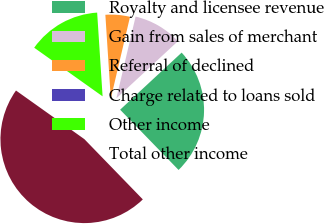Convert chart to OTSL. <chart><loc_0><loc_0><loc_500><loc_500><pie_chart><fcel>Royalty and licensee revenue<fcel>Gain from sales of merchant<fcel>Referral of declined<fcel>Charge related to loans sold<fcel>Other income<fcel>Total other income<nl><fcel>24.65%<fcel>9.42%<fcel>4.71%<fcel>0.0%<fcel>14.13%<fcel>47.1%<nl></chart> 